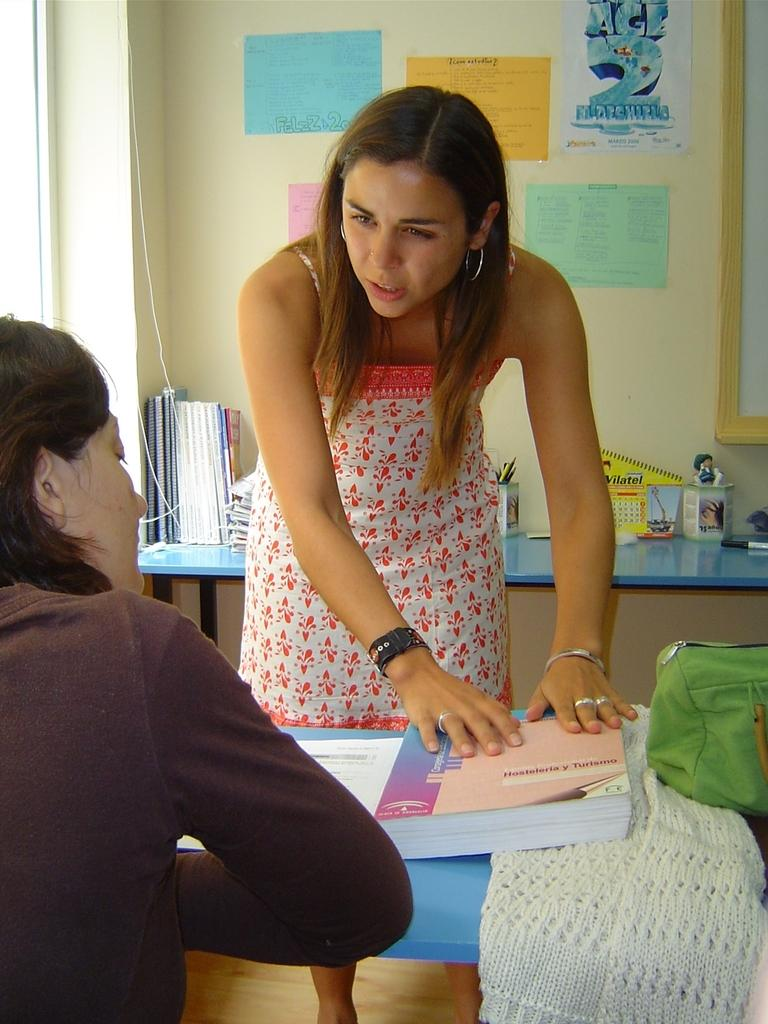How many people are in the image? There are two persons in the image. Can you describe the appearance of one of the persons? There is a lady person in the image, and she is wearing a red dress. What is the lady person doing in the image? The lady person is bending down. What can be seen on the wall in the background of the image? There are charts pasted on the wall in the background of the image. What type of thrill does the lady person's dad experience while watching her in the image? There is no mention of a dad or any thrill in the image, so it cannot be determined. 